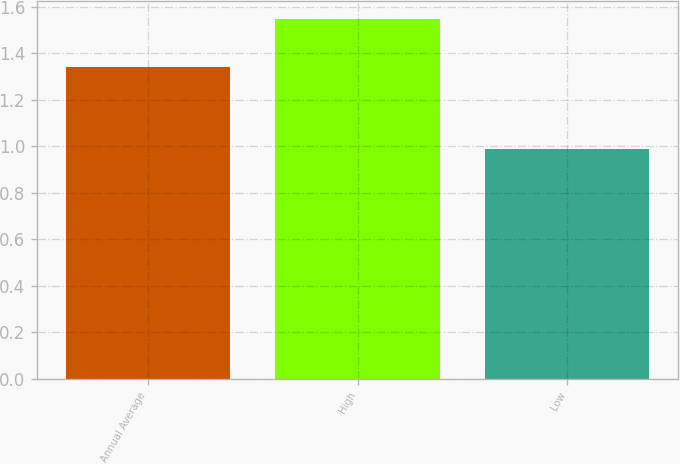Convert chart to OTSL. <chart><loc_0><loc_0><loc_500><loc_500><bar_chart><fcel>Annual Average<fcel>High<fcel>Low<nl><fcel>1.34<fcel>1.55<fcel>0.99<nl></chart> 